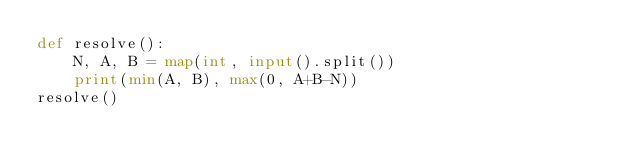Convert code to text. <code><loc_0><loc_0><loc_500><loc_500><_Python_>def resolve():
    N, A, B = map(int, input().split())
    print(min(A, B), max(0, A+B-N))
resolve()</code> 